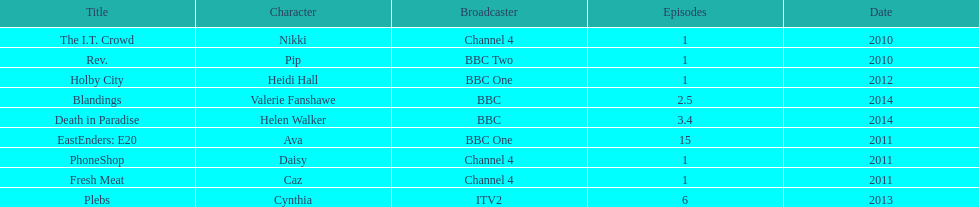Help me parse the entirety of this table. {'header': ['Title', 'Character', 'Broadcaster', 'Episodes', 'Date'], 'rows': [['The I.T. Crowd', 'Nikki', 'Channel 4', '1', '2010'], ['Rev.', 'Pip', 'BBC Two', '1', '2010'], ['Holby City', 'Heidi Hall', 'BBC One', '1', '2012'], ['Blandings', 'Valerie Fanshawe', 'BBC', '2.5', '2014'], ['Death in Paradise', 'Helen Walker', 'BBC', '3.4', '2014'], ['EastEnders: E20', 'Ava', 'BBC One', '15', '2011'], ['PhoneShop', 'Daisy', 'Channel 4', '1', '2011'], ['Fresh Meat', 'Caz', 'Channel 4', '1', '2011'], ['Plebs', 'Cynthia', 'ITV2', '6', '2013']]} What is the only role she played with broadcaster itv2? Cynthia. 